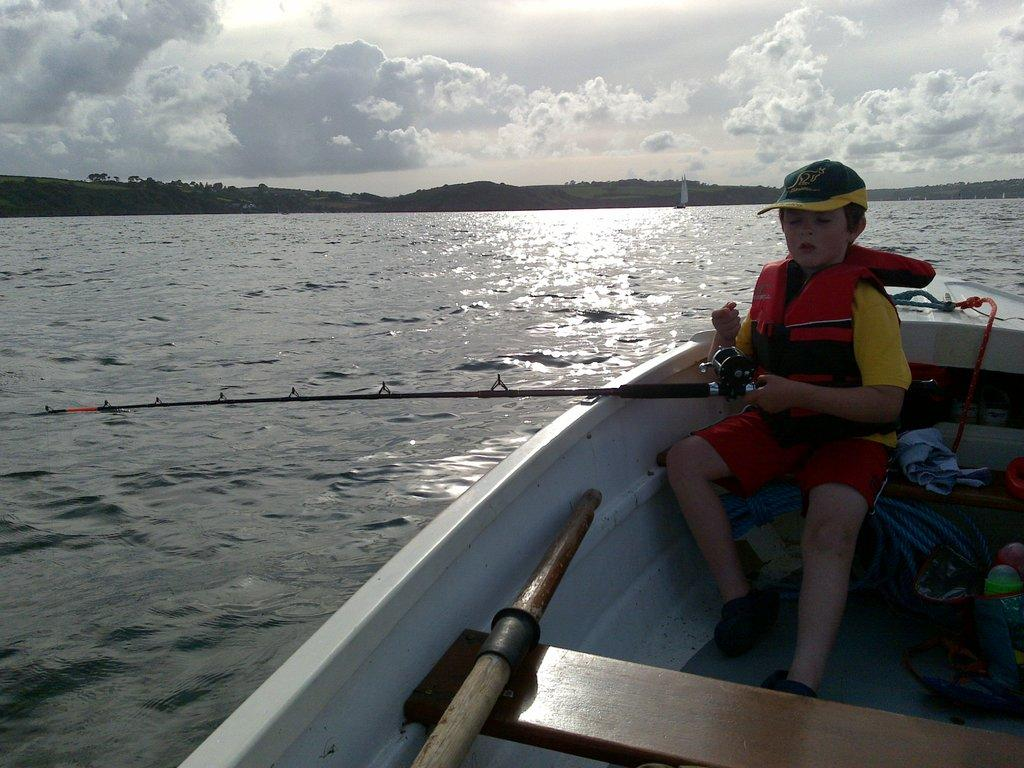What is the main subject of the image? The main subject of the image is a boy. What is the boy doing in the image? The boy is fishing in a boat. What color is the boy's jacket in the image? The boy is wearing a red color jacket. What color is the boy's cap in the image? The boy is wearing a yellow color cap. How would you describe the weather in the image? The sky is cloudy in the image, suggesting overcast or potentially rainy weather. What type of paint is being used by the boy to paint the nation in the image? There is no indication in the image that the boy is painting or representing a nation, nor is there any paint present. 